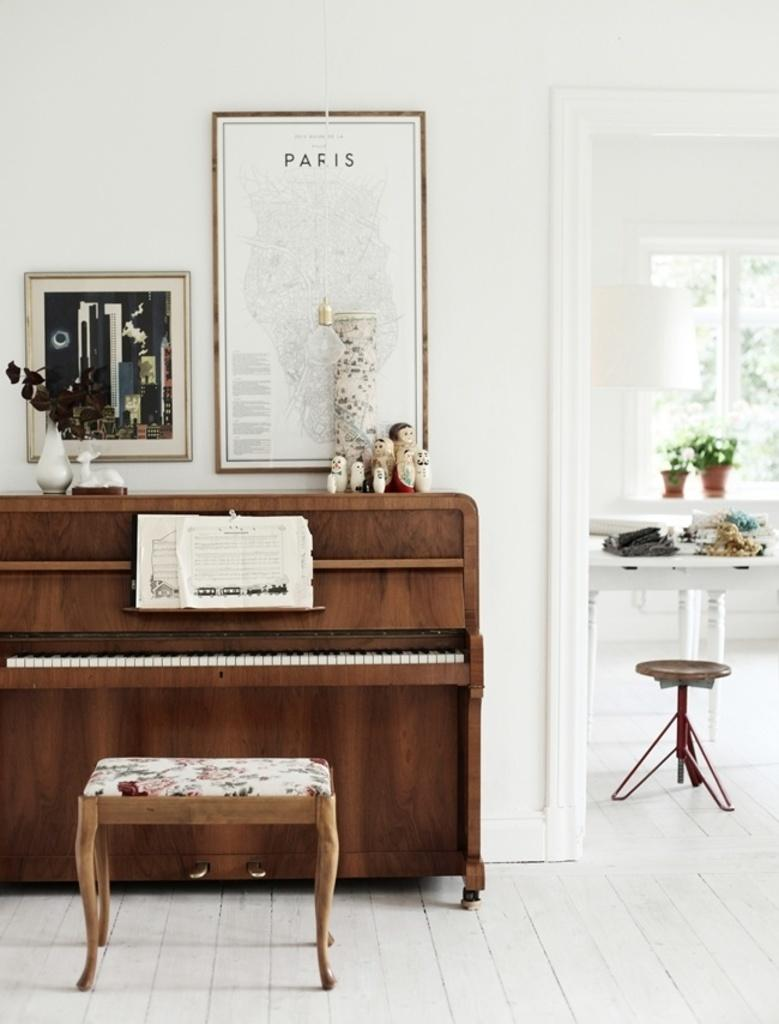What musical instrument is present in the image? There is a piano in the image. Is there any seating arrangement near the piano? Yes, there is a chair for a person to sit near the piano. What can be seen on the wall in the image? There is a photo frame on the wall. What items are placed on the table in the image? There are clothes on a table in the image. What type of sofa is located in the north part of the image? There is no sofa present in the image, and the concept of "north" is not applicable to a 2D image. 